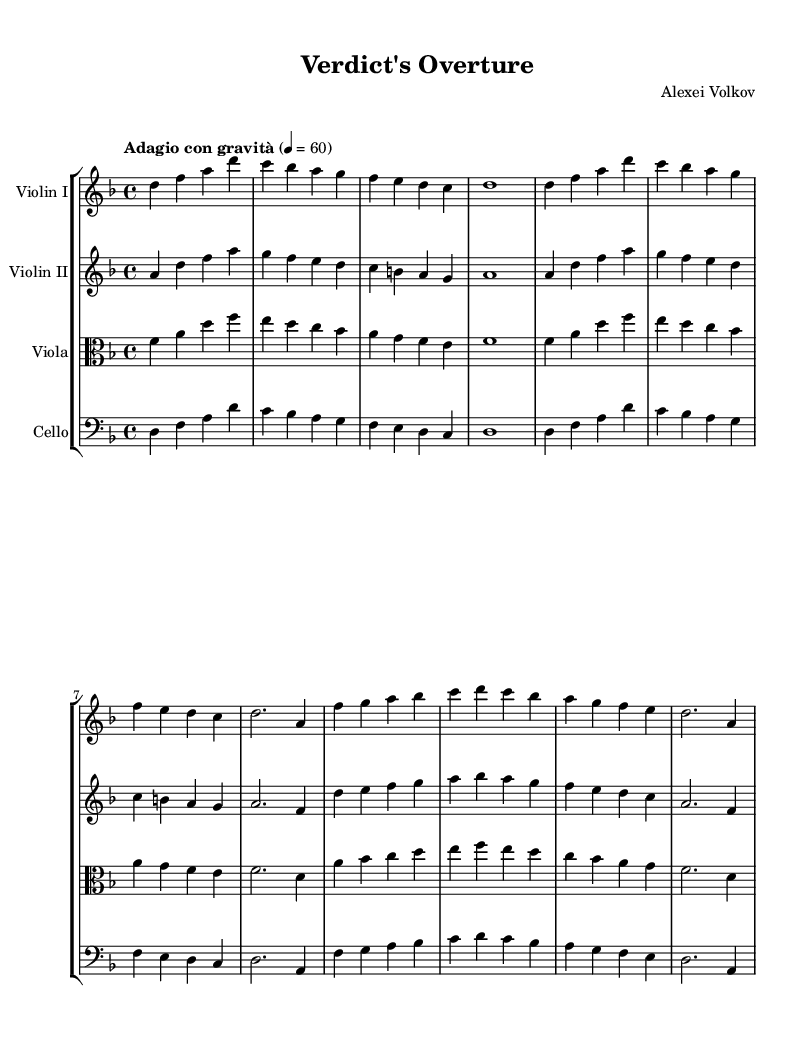What is the key signature of this music? The key signature is D minor, indicated by one flat (B flat) on the staff.
Answer: D minor What is the time signature of this piece? The time signature is 4/4, which means there are four beats in each measure.
Answer: 4/4 What tempo is indicated for the music? The tempo marking is "Adagio con gravità," suggesting a slow and solemn character.
Answer: Adagio con gravità How many measures are in the violin I part? Counting the measures in the violin I part includes four distinct measures for the introduction and themes, totaling eight measures altogether.
Answer: 8 measures Which instruments are included in the score? The score includes Violin I, Violin II, Viola, and Cello, as identified by their respective staves.
Answer: Violin I, Violin II, Viola, Cello What is the theme A's ending note in the violin I part? Theme A ends on the note A, which is the last note played before transitioning to theme B in the violin I part.
Answer: A What style does this orchestral score suggest for film usage? The orchestration and thematic material suggest a dramatic and emotional atmosphere fitting for a legal drama film.
Answer: Dramatic and emotional atmosphere 